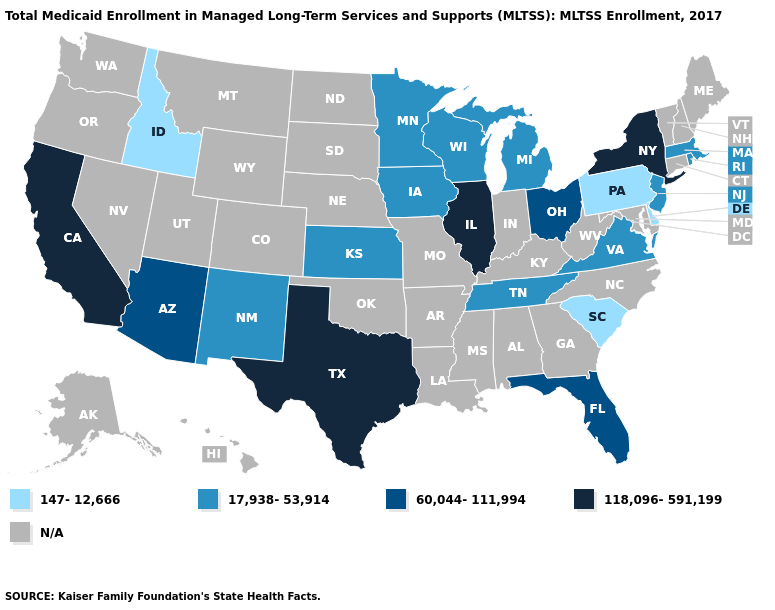What is the value of New Mexico?
Short answer required. 17,938-53,914. Name the states that have a value in the range 147-12,666?
Quick response, please. Delaware, Idaho, Pennsylvania, South Carolina. Does New York have the highest value in the USA?
Answer briefly. Yes. What is the value of Virginia?
Be succinct. 17,938-53,914. Does Pennsylvania have the lowest value in the USA?
Quick response, please. Yes. Name the states that have a value in the range N/A?
Keep it brief. Alabama, Alaska, Arkansas, Colorado, Connecticut, Georgia, Hawaii, Indiana, Kentucky, Louisiana, Maine, Maryland, Mississippi, Missouri, Montana, Nebraska, Nevada, New Hampshire, North Carolina, North Dakota, Oklahoma, Oregon, South Dakota, Utah, Vermont, Washington, West Virginia, Wyoming. What is the highest value in states that border Texas?
Keep it brief. 17,938-53,914. What is the value of Oklahoma?
Keep it brief. N/A. What is the value of Ohio?
Short answer required. 60,044-111,994. How many symbols are there in the legend?
Concise answer only. 5. Is the legend a continuous bar?
Write a very short answer. No. Among the states that border Missouri , does Illinois have the lowest value?
Short answer required. No. Does South Carolina have the highest value in the South?
Concise answer only. No. 